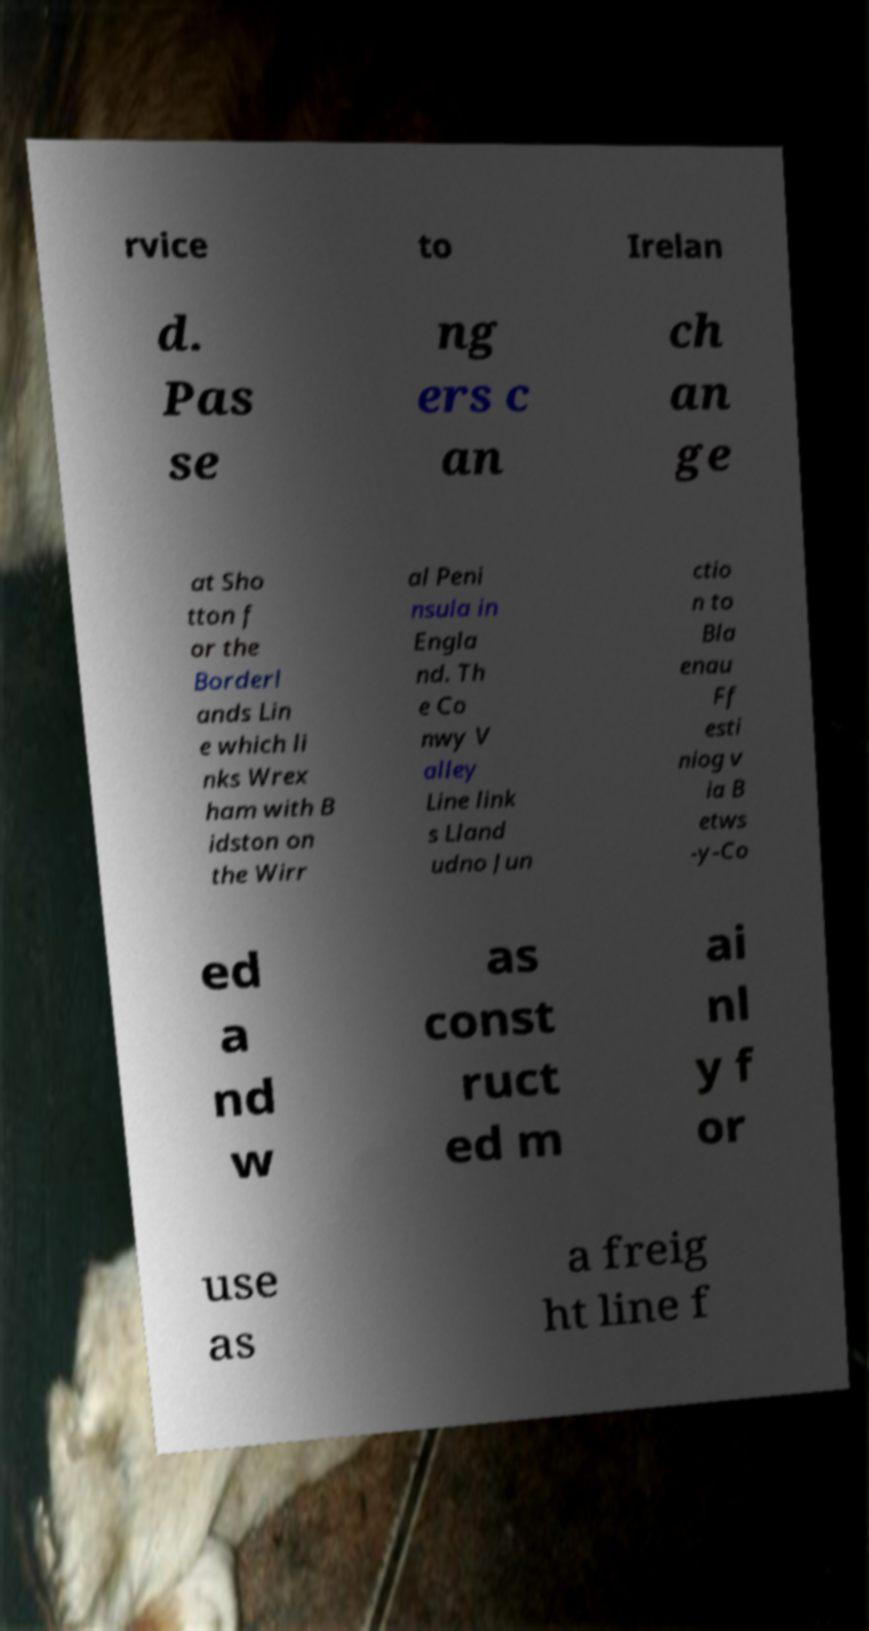There's text embedded in this image that I need extracted. Can you transcribe it verbatim? rvice to Irelan d. Pas se ng ers c an ch an ge at Sho tton f or the Borderl ands Lin e which li nks Wrex ham with B idston on the Wirr al Peni nsula in Engla nd. Th e Co nwy V alley Line link s Lland udno Jun ctio n to Bla enau Ff esti niog v ia B etws -y-Co ed a nd w as const ruct ed m ai nl y f or use as a freig ht line f 